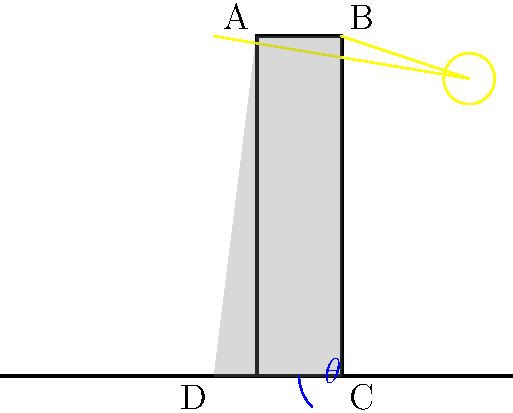In a surveillance photo taken on a clear day, you observe a building casting a shadow as shown in the diagram. The angle between the shadow and the ground is labeled $\theta$. If you know that this photo was taken in the northern hemisphere during summer, how would you determine whether it was taken in the morning or afternoon? To determine whether the photo was taken in the morning or afternoon, we need to analyze the position of the sun and the direction of the shadow:

1. In the northern hemisphere, the sun's apparent path across the sky is from east to west, passing through the southern part of the sky.

2. The shadow of an object always points away from the sun.

3. In the diagram, we can see that the shadow is cast towards the left side of the building.

4. Given that the photo was taken in the northern hemisphere during summer:
   - If the shadow points towards the west (left in the image), it indicates that the sun is in the east, meaning it's morning.
   - If the shadow points towards the east (right in the image), it indicates that the sun is in the west, meaning it's afternoon.

5. In this case, the shadow is pointing to the left, which we can assume is west.

6. Therefore, the sun must be in the east, indicating that the photo was taken in the morning.

7. The angle $\theta$ between the shadow and the ground would be smaller in the morning and larger in the afternoon, but this information alone is not sufficient to determine the time of day without knowing the exact latitude and date.
Answer: Morning 